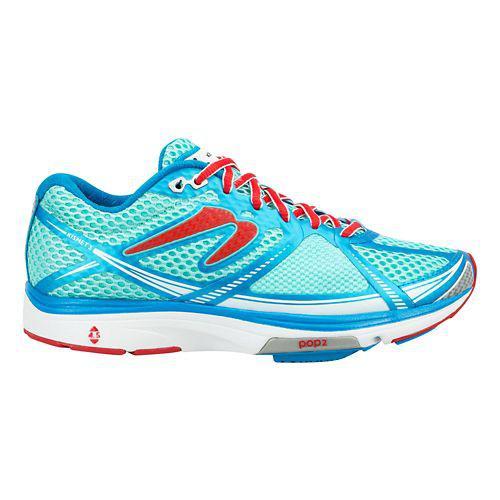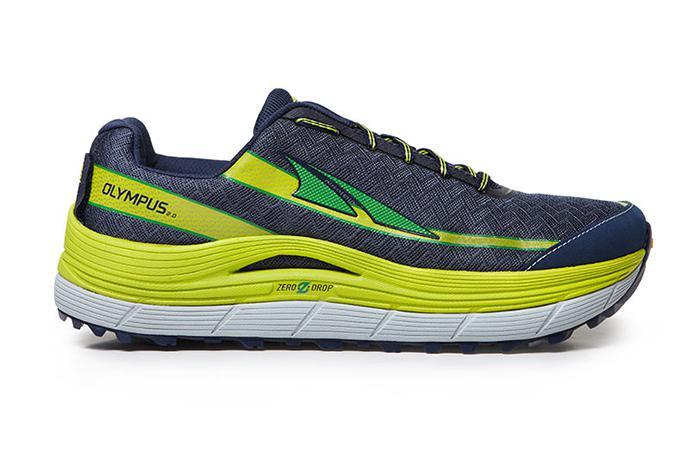The first image is the image on the left, the second image is the image on the right. Analyze the images presented: Is the assertion "In one image, a shoe featuring turquise, gray, and lime green is laced with turquoise colored strings, and is positioned so the toe section is angled towards the front." valid? Answer yes or no. No. The first image is the image on the left, the second image is the image on the right. Analyze the images presented: Is the assertion "Each image contains a single sneaker, and the sneakers in the right and left images face the same direction." valid? Answer yes or no. Yes. 